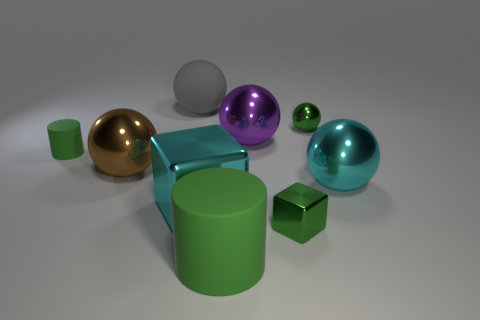Add 1 large cylinders. How many objects exist? 10 Subtract all big spheres. How many spheres are left? 1 Subtract all green blocks. How many blocks are left? 1 Subtract 1 cylinders. How many cylinders are left? 1 Subtract 0 yellow balls. How many objects are left? 9 Subtract all cubes. How many objects are left? 7 Subtract all red cubes. Subtract all cyan spheres. How many cubes are left? 2 Subtract all yellow blocks. How many brown balls are left? 1 Subtract all large cubes. Subtract all small cyan matte things. How many objects are left? 8 Add 7 purple objects. How many purple objects are left? 8 